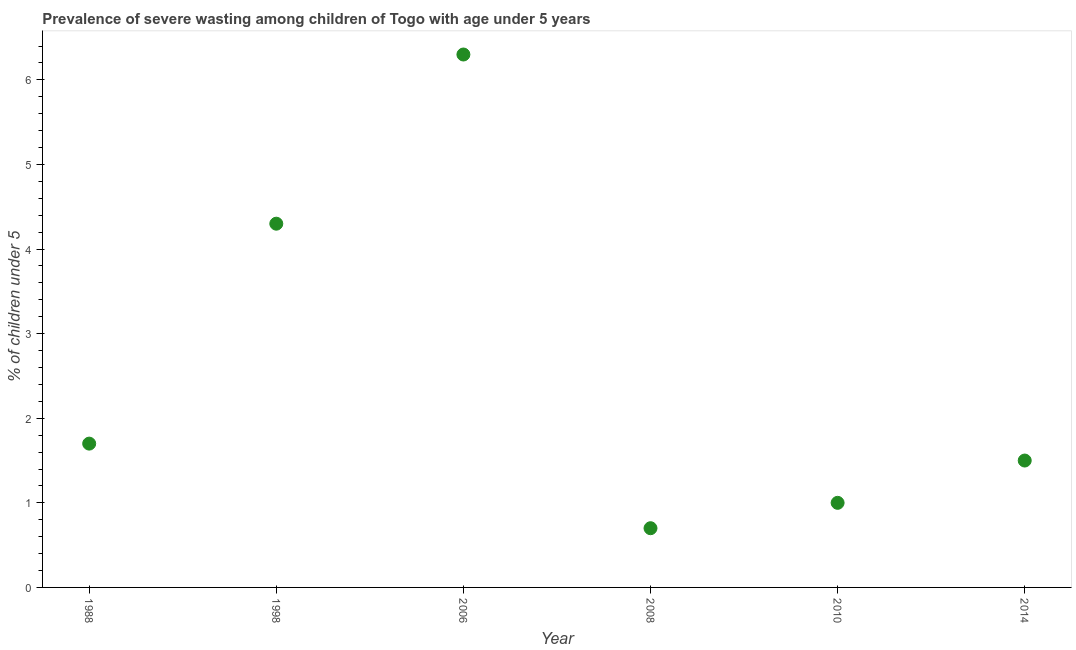What is the prevalence of severe wasting in 2014?
Ensure brevity in your answer.  1.5. Across all years, what is the maximum prevalence of severe wasting?
Provide a short and direct response. 6.3. Across all years, what is the minimum prevalence of severe wasting?
Offer a terse response. 0.7. What is the sum of the prevalence of severe wasting?
Provide a short and direct response. 15.5. What is the difference between the prevalence of severe wasting in 2008 and 2010?
Keep it short and to the point. -0.3. What is the average prevalence of severe wasting per year?
Ensure brevity in your answer.  2.58. What is the median prevalence of severe wasting?
Provide a short and direct response. 1.6. What is the ratio of the prevalence of severe wasting in 1988 to that in 2010?
Provide a succinct answer. 1.7. Is the prevalence of severe wasting in 1988 less than that in 2010?
Your answer should be compact. No. What is the difference between the highest and the second highest prevalence of severe wasting?
Your response must be concise. 2. What is the difference between the highest and the lowest prevalence of severe wasting?
Your answer should be very brief. 5.6. In how many years, is the prevalence of severe wasting greater than the average prevalence of severe wasting taken over all years?
Your answer should be compact. 2. How many dotlines are there?
Make the answer very short. 1. Does the graph contain any zero values?
Provide a short and direct response. No. Does the graph contain grids?
Provide a succinct answer. No. What is the title of the graph?
Provide a succinct answer. Prevalence of severe wasting among children of Togo with age under 5 years. What is the label or title of the X-axis?
Keep it short and to the point. Year. What is the label or title of the Y-axis?
Give a very brief answer.  % of children under 5. What is the  % of children under 5 in 1988?
Ensure brevity in your answer.  1.7. What is the  % of children under 5 in 1998?
Your answer should be very brief. 4.3. What is the  % of children under 5 in 2006?
Offer a very short reply. 6.3. What is the  % of children under 5 in 2008?
Your response must be concise. 0.7. What is the difference between the  % of children under 5 in 1988 and 2014?
Ensure brevity in your answer.  0.2. What is the difference between the  % of children under 5 in 1998 and 2006?
Your response must be concise. -2. What is the difference between the  % of children under 5 in 1998 and 2010?
Give a very brief answer. 3.3. What is the difference between the  % of children under 5 in 1998 and 2014?
Ensure brevity in your answer.  2.8. What is the difference between the  % of children under 5 in 2006 and 2010?
Provide a short and direct response. 5.3. What is the ratio of the  % of children under 5 in 1988 to that in 1998?
Your answer should be compact. 0.4. What is the ratio of the  % of children under 5 in 1988 to that in 2006?
Offer a terse response. 0.27. What is the ratio of the  % of children under 5 in 1988 to that in 2008?
Your answer should be very brief. 2.43. What is the ratio of the  % of children under 5 in 1988 to that in 2010?
Offer a very short reply. 1.7. What is the ratio of the  % of children under 5 in 1988 to that in 2014?
Ensure brevity in your answer.  1.13. What is the ratio of the  % of children under 5 in 1998 to that in 2006?
Keep it short and to the point. 0.68. What is the ratio of the  % of children under 5 in 1998 to that in 2008?
Give a very brief answer. 6.14. What is the ratio of the  % of children under 5 in 1998 to that in 2010?
Offer a terse response. 4.3. What is the ratio of the  % of children under 5 in 1998 to that in 2014?
Keep it short and to the point. 2.87. What is the ratio of the  % of children under 5 in 2006 to that in 2008?
Provide a short and direct response. 9. What is the ratio of the  % of children under 5 in 2008 to that in 2010?
Give a very brief answer. 0.7. What is the ratio of the  % of children under 5 in 2008 to that in 2014?
Your answer should be compact. 0.47. What is the ratio of the  % of children under 5 in 2010 to that in 2014?
Offer a terse response. 0.67. 